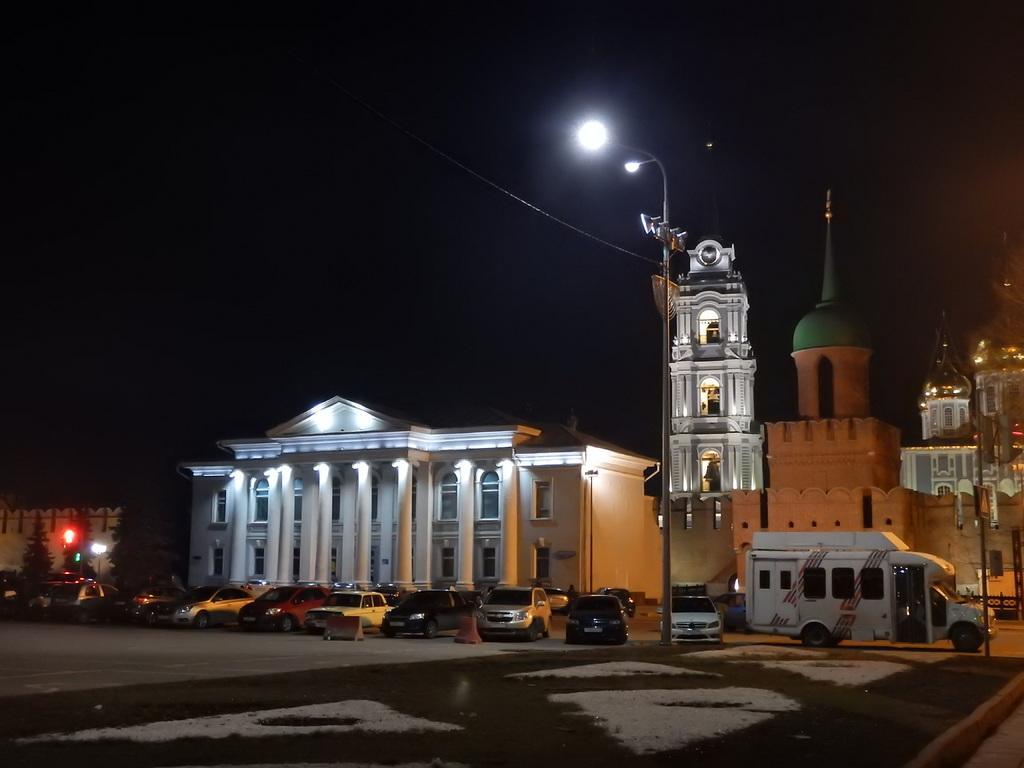Please provide a concise description of this image. In this image we can see a building, trees, vehicles, light pole and road. In the background there is a sky. 